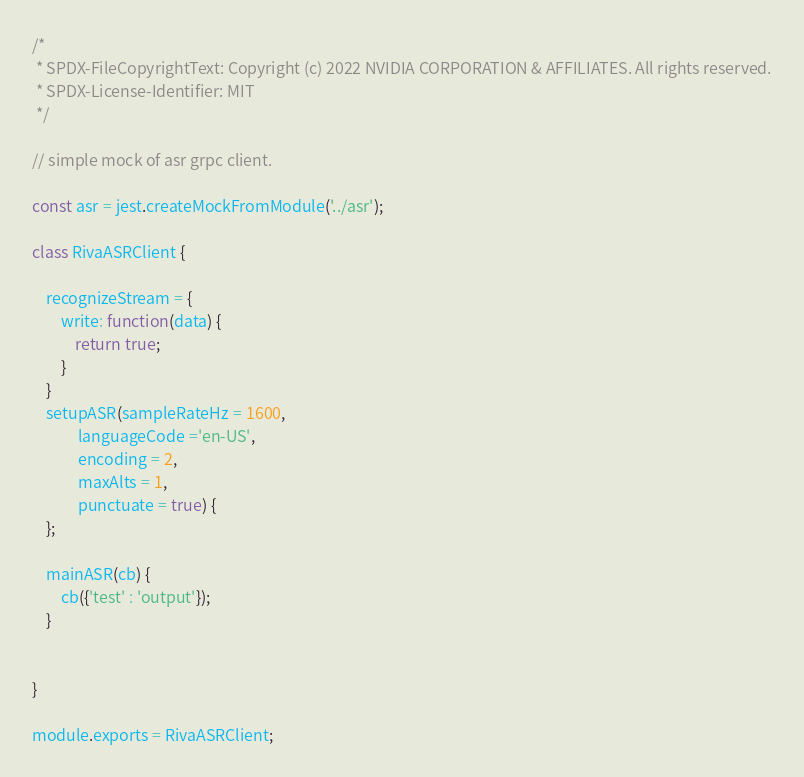Convert code to text. <code><loc_0><loc_0><loc_500><loc_500><_JavaScript_>/*
 * SPDX-FileCopyrightText: Copyright (c) 2022 NVIDIA CORPORATION & AFFILIATES. All rights reserved.
 * SPDX-License-Identifier: MIT
 */

// simple mock of asr grpc client.

const asr = jest.createMockFromModule('../asr');

class RivaASRClient {

    recognizeStream = {
        write: function(data) {
            return true;
        }
    }
    setupASR(sampleRateHz = 1600,
             languageCode ='en-US',
             encoding = 2,
             maxAlts = 1,
             punctuate = true) {
    };

    mainASR(cb) {
        cb({'test' : 'output'});
    }


}

module.exports = RivaASRClient;
</code> 